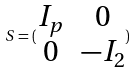Convert formula to latex. <formula><loc_0><loc_0><loc_500><loc_500>S = ( \begin{matrix} I _ { p } & 0 \\ 0 & - I _ { 2 } \end{matrix} )</formula> 